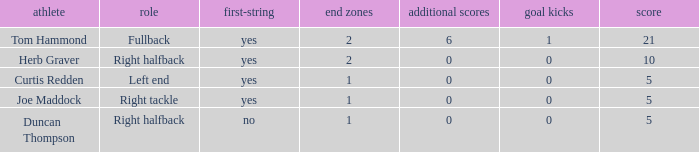Name the most touchdowns for field goals being 1 2.0. 